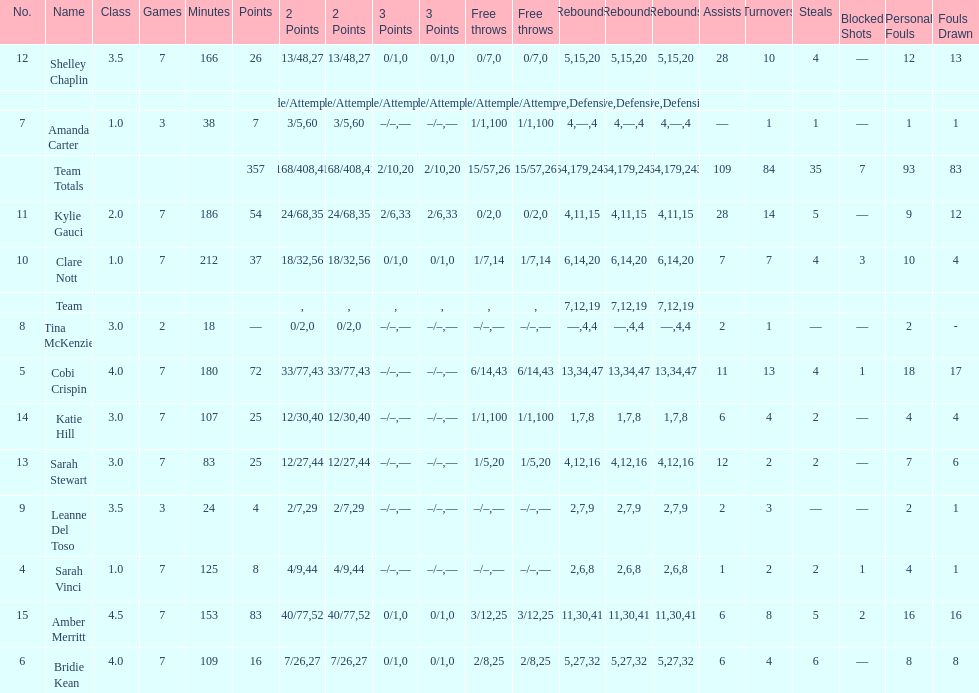After completing seven games, how many players managed to score above 30 points? 4. 